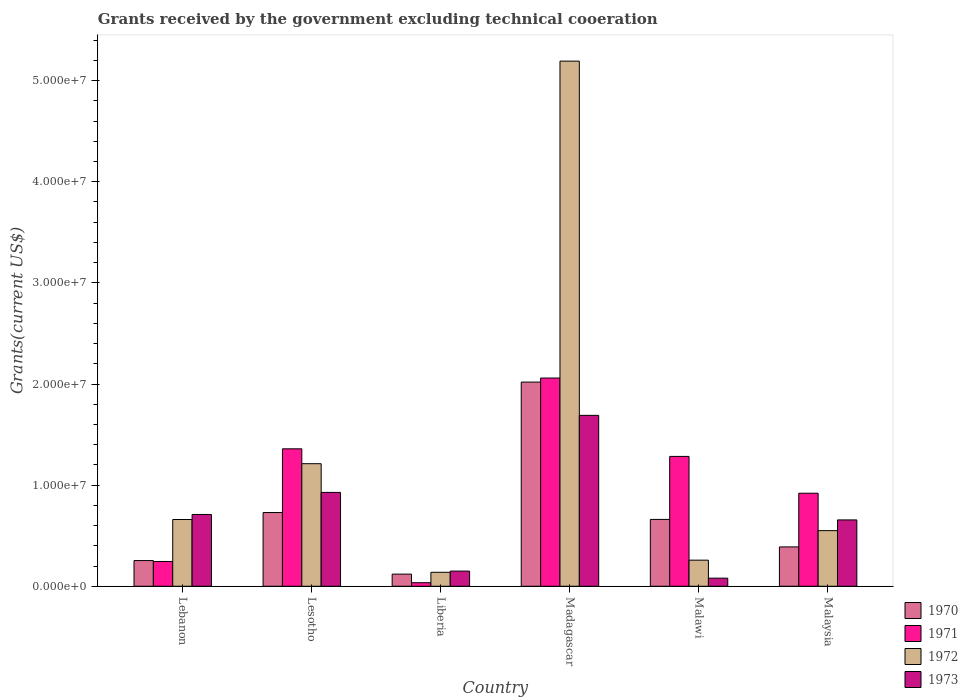How many groups of bars are there?
Give a very brief answer. 6. Are the number of bars on each tick of the X-axis equal?
Ensure brevity in your answer.  Yes. What is the label of the 6th group of bars from the left?
Offer a terse response. Malaysia. What is the total grants received by the government in 1972 in Lesotho?
Give a very brief answer. 1.21e+07. Across all countries, what is the maximum total grants received by the government in 1973?
Ensure brevity in your answer.  1.69e+07. Across all countries, what is the minimum total grants received by the government in 1970?
Provide a short and direct response. 1.20e+06. In which country was the total grants received by the government in 1973 maximum?
Provide a succinct answer. Madagascar. In which country was the total grants received by the government in 1970 minimum?
Offer a terse response. Liberia. What is the total total grants received by the government in 1970 in the graph?
Provide a succinct answer. 4.17e+07. What is the difference between the total grants received by the government in 1973 in Lesotho and that in Malaysia?
Provide a succinct answer. 2.72e+06. What is the difference between the total grants received by the government in 1972 in Malaysia and the total grants received by the government in 1973 in Madagascar?
Ensure brevity in your answer.  -1.14e+07. What is the average total grants received by the government in 1970 per country?
Provide a short and direct response. 6.95e+06. What is the difference between the total grants received by the government of/in 1970 and total grants received by the government of/in 1971 in Madagascar?
Provide a succinct answer. -4.00e+05. What is the ratio of the total grants received by the government in 1970 in Lebanon to that in Madagascar?
Offer a terse response. 0.13. Is the difference between the total grants received by the government in 1970 in Lebanon and Liberia greater than the difference between the total grants received by the government in 1971 in Lebanon and Liberia?
Offer a very short reply. No. What is the difference between the highest and the second highest total grants received by the government in 1972?
Provide a short and direct response. 4.53e+07. What is the difference between the highest and the lowest total grants received by the government in 1972?
Give a very brief answer. 5.06e+07. What does the 1st bar from the left in Madagascar represents?
Offer a terse response. 1970. Is it the case that in every country, the sum of the total grants received by the government in 1970 and total grants received by the government in 1972 is greater than the total grants received by the government in 1973?
Keep it short and to the point. Yes. How many bars are there?
Ensure brevity in your answer.  24. Are all the bars in the graph horizontal?
Give a very brief answer. No. What is the difference between two consecutive major ticks on the Y-axis?
Give a very brief answer. 1.00e+07. Does the graph contain grids?
Your answer should be compact. No. How many legend labels are there?
Ensure brevity in your answer.  4. How are the legend labels stacked?
Your answer should be compact. Vertical. What is the title of the graph?
Your answer should be very brief. Grants received by the government excluding technical cooeration. Does "1989" appear as one of the legend labels in the graph?
Your response must be concise. No. What is the label or title of the Y-axis?
Offer a very short reply. Grants(current US$). What is the Grants(current US$) in 1970 in Lebanon?
Keep it short and to the point. 2.54e+06. What is the Grants(current US$) of 1971 in Lebanon?
Your response must be concise. 2.45e+06. What is the Grants(current US$) in 1972 in Lebanon?
Ensure brevity in your answer.  6.60e+06. What is the Grants(current US$) of 1973 in Lebanon?
Your response must be concise. 7.10e+06. What is the Grants(current US$) of 1970 in Lesotho?
Offer a terse response. 7.29e+06. What is the Grants(current US$) of 1971 in Lesotho?
Offer a very short reply. 1.36e+07. What is the Grants(current US$) of 1972 in Lesotho?
Ensure brevity in your answer.  1.21e+07. What is the Grants(current US$) of 1973 in Lesotho?
Provide a succinct answer. 9.28e+06. What is the Grants(current US$) of 1970 in Liberia?
Make the answer very short. 1.20e+06. What is the Grants(current US$) of 1971 in Liberia?
Your response must be concise. 3.50e+05. What is the Grants(current US$) in 1972 in Liberia?
Keep it short and to the point. 1.38e+06. What is the Grants(current US$) in 1973 in Liberia?
Your response must be concise. 1.50e+06. What is the Grants(current US$) of 1970 in Madagascar?
Your response must be concise. 2.02e+07. What is the Grants(current US$) in 1971 in Madagascar?
Provide a short and direct response. 2.06e+07. What is the Grants(current US$) in 1972 in Madagascar?
Ensure brevity in your answer.  5.19e+07. What is the Grants(current US$) in 1973 in Madagascar?
Your answer should be very brief. 1.69e+07. What is the Grants(current US$) of 1970 in Malawi?
Offer a terse response. 6.61e+06. What is the Grants(current US$) in 1971 in Malawi?
Your answer should be compact. 1.28e+07. What is the Grants(current US$) of 1972 in Malawi?
Your answer should be compact. 2.58e+06. What is the Grants(current US$) of 1973 in Malawi?
Offer a very short reply. 8.00e+05. What is the Grants(current US$) of 1970 in Malaysia?
Provide a short and direct response. 3.89e+06. What is the Grants(current US$) of 1971 in Malaysia?
Your answer should be compact. 9.20e+06. What is the Grants(current US$) of 1972 in Malaysia?
Offer a very short reply. 5.50e+06. What is the Grants(current US$) of 1973 in Malaysia?
Your answer should be very brief. 6.56e+06. Across all countries, what is the maximum Grants(current US$) in 1970?
Your response must be concise. 2.02e+07. Across all countries, what is the maximum Grants(current US$) in 1971?
Keep it short and to the point. 2.06e+07. Across all countries, what is the maximum Grants(current US$) in 1972?
Ensure brevity in your answer.  5.19e+07. Across all countries, what is the maximum Grants(current US$) of 1973?
Keep it short and to the point. 1.69e+07. Across all countries, what is the minimum Grants(current US$) of 1970?
Give a very brief answer. 1.20e+06. Across all countries, what is the minimum Grants(current US$) of 1971?
Give a very brief answer. 3.50e+05. Across all countries, what is the minimum Grants(current US$) in 1972?
Your response must be concise. 1.38e+06. Across all countries, what is the minimum Grants(current US$) in 1973?
Make the answer very short. 8.00e+05. What is the total Grants(current US$) of 1970 in the graph?
Ensure brevity in your answer.  4.17e+07. What is the total Grants(current US$) of 1971 in the graph?
Your answer should be very brief. 5.90e+07. What is the total Grants(current US$) of 1972 in the graph?
Offer a very short reply. 8.01e+07. What is the total Grants(current US$) of 1973 in the graph?
Your answer should be very brief. 4.21e+07. What is the difference between the Grants(current US$) of 1970 in Lebanon and that in Lesotho?
Keep it short and to the point. -4.75e+06. What is the difference between the Grants(current US$) in 1971 in Lebanon and that in Lesotho?
Offer a very short reply. -1.11e+07. What is the difference between the Grants(current US$) of 1972 in Lebanon and that in Lesotho?
Offer a very short reply. -5.52e+06. What is the difference between the Grants(current US$) of 1973 in Lebanon and that in Lesotho?
Your answer should be very brief. -2.18e+06. What is the difference between the Grants(current US$) in 1970 in Lebanon and that in Liberia?
Provide a succinct answer. 1.34e+06. What is the difference between the Grants(current US$) in 1971 in Lebanon and that in Liberia?
Offer a very short reply. 2.10e+06. What is the difference between the Grants(current US$) of 1972 in Lebanon and that in Liberia?
Give a very brief answer. 5.22e+06. What is the difference between the Grants(current US$) of 1973 in Lebanon and that in Liberia?
Your response must be concise. 5.60e+06. What is the difference between the Grants(current US$) in 1970 in Lebanon and that in Madagascar?
Offer a very short reply. -1.76e+07. What is the difference between the Grants(current US$) in 1971 in Lebanon and that in Madagascar?
Ensure brevity in your answer.  -1.81e+07. What is the difference between the Grants(current US$) of 1972 in Lebanon and that in Madagascar?
Provide a succinct answer. -4.53e+07. What is the difference between the Grants(current US$) in 1973 in Lebanon and that in Madagascar?
Offer a very short reply. -9.80e+06. What is the difference between the Grants(current US$) of 1970 in Lebanon and that in Malawi?
Give a very brief answer. -4.07e+06. What is the difference between the Grants(current US$) in 1971 in Lebanon and that in Malawi?
Your response must be concise. -1.04e+07. What is the difference between the Grants(current US$) of 1972 in Lebanon and that in Malawi?
Your answer should be very brief. 4.02e+06. What is the difference between the Grants(current US$) in 1973 in Lebanon and that in Malawi?
Your response must be concise. 6.30e+06. What is the difference between the Grants(current US$) in 1970 in Lebanon and that in Malaysia?
Keep it short and to the point. -1.35e+06. What is the difference between the Grants(current US$) of 1971 in Lebanon and that in Malaysia?
Your response must be concise. -6.75e+06. What is the difference between the Grants(current US$) of 1972 in Lebanon and that in Malaysia?
Provide a short and direct response. 1.10e+06. What is the difference between the Grants(current US$) in 1973 in Lebanon and that in Malaysia?
Offer a terse response. 5.40e+05. What is the difference between the Grants(current US$) of 1970 in Lesotho and that in Liberia?
Make the answer very short. 6.09e+06. What is the difference between the Grants(current US$) in 1971 in Lesotho and that in Liberia?
Keep it short and to the point. 1.32e+07. What is the difference between the Grants(current US$) in 1972 in Lesotho and that in Liberia?
Offer a very short reply. 1.07e+07. What is the difference between the Grants(current US$) of 1973 in Lesotho and that in Liberia?
Provide a succinct answer. 7.78e+06. What is the difference between the Grants(current US$) in 1970 in Lesotho and that in Madagascar?
Your answer should be compact. -1.29e+07. What is the difference between the Grants(current US$) of 1971 in Lesotho and that in Madagascar?
Your answer should be very brief. -7.00e+06. What is the difference between the Grants(current US$) of 1972 in Lesotho and that in Madagascar?
Your response must be concise. -3.98e+07. What is the difference between the Grants(current US$) in 1973 in Lesotho and that in Madagascar?
Your response must be concise. -7.62e+06. What is the difference between the Grants(current US$) of 1970 in Lesotho and that in Malawi?
Your answer should be very brief. 6.80e+05. What is the difference between the Grants(current US$) of 1971 in Lesotho and that in Malawi?
Make the answer very short. 7.50e+05. What is the difference between the Grants(current US$) of 1972 in Lesotho and that in Malawi?
Keep it short and to the point. 9.54e+06. What is the difference between the Grants(current US$) of 1973 in Lesotho and that in Malawi?
Provide a succinct answer. 8.48e+06. What is the difference between the Grants(current US$) of 1970 in Lesotho and that in Malaysia?
Offer a very short reply. 3.40e+06. What is the difference between the Grants(current US$) in 1971 in Lesotho and that in Malaysia?
Your response must be concise. 4.39e+06. What is the difference between the Grants(current US$) in 1972 in Lesotho and that in Malaysia?
Your response must be concise. 6.62e+06. What is the difference between the Grants(current US$) in 1973 in Lesotho and that in Malaysia?
Ensure brevity in your answer.  2.72e+06. What is the difference between the Grants(current US$) in 1970 in Liberia and that in Madagascar?
Ensure brevity in your answer.  -1.90e+07. What is the difference between the Grants(current US$) of 1971 in Liberia and that in Madagascar?
Make the answer very short. -2.02e+07. What is the difference between the Grants(current US$) in 1972 in Liberia and that in Madagascar?
Give a very brief answer. -5.06e+07. What is the difference between the Grants(current US$) of 1973 in Liberia and that in Madagascar?
Your answer should be compact. -1.54e+07. What is the difference between the Grants(current US$) of 1970 in Liberia and that in Malawi?
Offer a very short reply. -5.41e+06. What is the difference between the Grants(current US$) of 1971 in Liberia and that in Malawi?
Offer a terse response. -1.25e+07. What is the difference between the Grants(current US$) in 1972 in Liberia and that in Malawi?
Your answer should be compact. -1.20e+06. What is the difference between the Grants(current US$) in 1973 in Liberia and that in Malawi?
Your answer should be compact. 7.00e+05. What is the difference between the Grants(current US$) in 1970 in Liberia and that in Malaysia?
Keep it short and to the point. -2.69e+06. What is the difference between the Grants(current US$) in 1971 in Liberia and that in Malaysia?
Offer a terse response. -8.85e+06. What is the difference between the Grants(current US$) of 1972 in Liberia and that in Malaysia?
Your response must be concise. -4.12e+06. What is the difference between the Grants(current US$) in 1973 in Liberia and that in Malaysia?
Give a very brief answer. -5.06e+06. What is the difference between the Grants(current US$) of 1970 in Madagascar and that in Malawi?
Provide a short and direct response. 1.36e+07. What is the difference between the Grants(current US$) of 1971 in Madagascar and that in Malawi?
Give a very brief answer. 7.75e+06. What is the difference between the Grants(current US$) in 1972 in Madagascar and that in Malawi?
Provide a short and direct response. 4.94e+07. What is the difference between the Grants(current US$) in 1973 in Madagascar and that in Malawi?
Offer a very short reply. 1.61e+07. What is the difference between the Grants(current US$) in 1970 in Madagascar and that in Malaysia?
Give a very brief answer. 1.63e+07. What is the difference between the Grants(current US$) of 1971 in Madagascar and that in Malaysia?
Your response must be concise. 1.14e+07. What is the difference between the Grants(current US$) in 1972 in Madagascar and that in Malaysia?
Offer a terse response. 4.64e+07. What is the difference between the Grants(current US$) of 1973 in Madagascar and that in Malaysia?
Provide a succinct answer. 1.03e+07. What is the difference between the Grants(current US$) of 1970 in Malawi and that in Malaysia?
Provide a succinct answer. 2.72e+06. What is the difference between the Grants(current US$) in 1971 in Malawi and that in Malaysia?
Make the answer very short. 3.64e+06. What is the difference between the Grants(current US$) of 1972 in Malawi and that in Malaysia?
Your answer should be very brief. -2.92e+06. What is the difference between the Grants(current US$) of 1973 in Malawi and that in Malaysia?
Offer a very short reply. -5.76e+06. What is the difference between the Grants(current US$) of 1970 in Lebanon and the Grants(current US$) of 1971 in Lesotho?
Provide a short and direct response. -1.10e+07. What is the difference between the Grants(current US$) of 1970 in Lebanon and the Grants(current US$) of 1972 in Lesotho?
Ensure brevity in your answer.  -9.58e+06. What is the difference between the Grants(current US$) of 1970 in Lebanon and the Grants(current US$) of 1973 in Lesotho?
Your answer should be very brief. -6.74e+06. What is the difference between the Grants(current US$) in 1971 in Lebanon and the Grants(current US$) in 1972 in Lesotho?
Make the answer very short. -9.67e+06. What is the difference between the Grants(current US$) in 1971 in Lebanon and the Grants(current US$) in 1973 in Lesotho?
Keep it short and to the point. -6.83e+06. What is the difference between the Grants(current US$) in 1972 in Lebanon and the Grants(current US$) in 1973 in Lesotho?
Your answer should be compact. -2.68e+06. What is the difference between the Grants(current US$) of 1970 in Lebanon and the Grants(current US$) of 1971 in Liberia?
Keep it short and to the point. 2.19e+06. What is the difference between the Grants(current US$) in 1970 in Lebanon and the Grants(current US$) in 1972 in Liberia?
Give a very brief answer. 1.16e+06. What is the difference between the Grants(current US$) in 1970 in Lebanon and the Grants(current US$) in 1973 in Liberia?
Your answer should be very brief. 1.04e+06. What is the difference between the Grants(current US$) in 1971 in Lebanon and the Grants(current US$) in 1972 in Liberia?
Provide a short and direct response. 1.07e+06. What is the difference between the Grants(current US$) of 1971 in Lebanon and the Grants(current US$) of 1973 in Liberia?
Make the answer very short. 9.50e+05. What is the difference between the Grants(current US$) in 1972 in Lebanon and the Grants(current US$) in 1973 in Liberia?
Give a very brief answer. 5.10e+06. What is the difference between the Grants(current US$) in 1970 in Lebanon and the Grants(current US$) in 1971 in Madagascar?
Make the answer very short. -1.80e+07. What is the difference between the Grants(current US$) in 1970 in Lebanon and the Grants(current US$) in 1972 in Madagascar?
Your answer should be very brief. -4.94e+07. What is the difference between the Grants(current US$) in 1970 in Lebanon and the Grants(current US$) in 1973 in Madagascar?
Your response must be concise. -1.44e+07. What is the difference between the Grants(current US$) in 1971 in Lebanon and the Grants(current US$) in 1972 in Madagascar?
Provide a succinct answer. -4.95e+07. What is the difference between the Grants(current US$) of 1971 in Lebanon and the Grants(current US$) of 1973 in Madagascar?
Offer a terse response. -1.44e+07. What is the difference between the Grants(current US$) in 1972 in Lebanon and the Grants(current US$) in 1973 in Madagascar?
Make the answer very short. -1.03e+07. What is the difference between the Grants(current US$) of 1970 in Lebanon and the Grants(current US$) of 1971 in Malawi?
Ensure brevity in your answer.  -1.03e+07. What is the difference between the Grants(current US$) in 1970 in Lebanon and the Grants(current US$) in 1972 in Malawi?
Provide a succinct answer. -4.00e+04. What is the difference between the Grants(current US$) in 1970 in Lebanon and the Grants(current US$) in 1973 in Malawi?
Your answer should be very brief. 1.74e+06. What is the difference between the Grants(current US$) in 1971 in Lebanon and the Grants(current US$) in 1972 in Malawi?
Offer a terse response. -1.30e+05. What is the difference between the Grants(current US$) in 1971 in Lebanon and the Grants(current US$) in 1973 in Malawi?
Make the answer very short. 1.65e+06. What is the difference between the Grants(current US$) in 1972 in Lebanon and the Grants(current US$) in 1973 in Malawi?
Your response must be concise. 5.80e+06. What is the difference between the Grants(current US$) of 1970 in Lebanon and the Grants(current US$) of 1971 in Malaysia?
Offer a very short reply. -6.66e+06. What is the difference between the Grants(current US$) of 1970 in Lebanon and the Grants(current US$) of 1972 in Malaysia?
Your response must be concise. -2.96e+06. What is the difference between the Grants(current US$) in 1970 in Lebanon and the Grants(current US$) in 1973 in Malaysia?
Offer a terse response. -4.02e+06. What is the difference between the Grants(current US$) in 1971 in Lebanon and the Grants(current US$) in 1972 in Malaysia?
Offer a very short reply. -3.05e+06. What is the difference between the Grants(current US$) in 1971 in Lebanon and the Grants(current US$) in 1973 in Malaysia?
Keep it short and to the point. -4.11e+06. What is the difference between the Grants(current US$) of 1972 in Lebanon and the Grants(current US$) of 1973 in Malaysia?
Offer a terse response. 4.00e+04. What is the difference between the Grants(current US$) in 1970 in Lesotho and the Grants(current US$) in 1971 in Liberia?
Give a very brief answer. 6.94e+06. What is the difference between the Grants(current US$) of 1970 in Lesotho and the Grants(current US$) of 1972 in Liberia?
Make the answer very short. 5.91e+06. What is the difference between the Grants(current US$) in 1970 in Lesotho and the Grants(current US$) in 1973 in Liberia?
Your answer should be compact. 5.79e+06. What is the difference between the Grants(current US$) in 1971 in Lesotho and the Grants(current US$) in 1972 in Liberia?
Keep it short and to the point. 1.22e+07. What is the difference between the Grants(current US$) in 1971 in Lesotho and the Grants(current US$) in 1973 in Liberia?
Your response must be concise. 1.21e+07. What is the difference between the Grants(current US$) of 1972 in Lesotho and the Grants(current US$) of 1973 in Liberia?
Offer a terse response. 1.06e+07. What is the difference between the Grants(current US$) in 1970 in Lesotho and the Grants(current US$) in 1971 in Madagascar?
Give a very brief answer. -1.33e+07. What is the difference between the Grants(current US$) of 1970 in Lesotho and the Grants(current US$) of 1972 in Madagascar?
Your response must be concise. -4.46e+07. What is the difference between the Grants(current US$) of 1970 in Lesotho and the Grants(current US$) of 1973 in Madagascar?
Your answer should be compact. -9.61e+06. What is the difference between the Grants(current US$) of 1971 in Lesotho and the Grants(current US$) of 1972 in Madagascar?
Offer a very short reply. -3.83e+07. What is the difference between the Grants(current US$) of 1971 in Lesotho and the Grants(current US$) of 1973 in Madagascar?
Give a very brief answer. -3.31e+06. What is the difference between the Grants(current US$) of 1972 in Lesotho and the Grants(current US$) of 1973 in Madagascar?
Your answer should be very brief. -4.78e+06. What is the difference between the Grants(current US$) in 1970 in Lesotho and the Grants(current US$) in 1971 in Malawi?
Provide a succinct answer. -5.55e+06. What is the difference between the Grants(current US$) of 1970 in Lesotho and the Grants(current US$) of 1972 in Malawi?
Give a very brief answer. 4.71e+06. What is the difference between the Grants(current US$) of 1970 in Lesotho and the Grants(current US$) of 1973 in Malawi?
Your answer should be very brief. 6.49e+06. What is the difference between the Grants(current US$) in 1971 in Lesotho and the Grants(current US$) in 1972 in Malawi?
Offer a terse response. 1.10e+07. What is the difference between the Grants(current US$) of 1971 in Lesotho and the Grants(current US$) of 1973 in Malawi?
Offer a terse response. 1.28e+07. What is the difference between the Grants(current US$) in 1972 in Lesotho and the Grants(current US$) in 1973 in Malawi?
Provide a succinct answer. 1.13e+07. What is the difference between the Grants(current US$) in 1970 in Lesotho and the Grants(current US$) in 1971 in Malaysia?
Your answer should be compact. -1.91e+06. What is the difference between the Grants(current US$) of 1970 in Lesotho and the Grants(current US$) of 1972 in Malaysia?
Give a very brief answer. 1.79e+06. What is the difference between the Grants(current US$) in 1970 in Lesotho and the Grants(current US$) in 1973 in Malaysia?
Provide a succinct answer. 7.30e+05. What is the difference between the Grants(current US$) of 1971 in Lesotho and the Grants(current US$) of 1972 in Malaysia?
Offer a very short reply. 8.09e+06. What is the difference between the Grants(current US$) in 1971 in Lesotho and the Grants(current US$) in 1973 in Malaysia?
Offer a very short reply. 7.03e+06. What is the difference between the Grants(current US$) of 1972 in Lesotho and the Grants(current US$) of 1973 in Malaysia?
Keep it short and to the point. 5.56e+06. What is the difference between the Grants(current US$) in 1970 in Liberia and the Grants(current US$) in 1971 in Madagascar?
Provide a short and direct response. -1.94e+07. What is the difference between the Grants(current US$) in 1970 in Liberia and the Grants(current US$) in 1972 in Madagascar?
Your answer should be very brief. -5.07e+07. What is the difference between the Grants(current US$) of 1970 in Liberia and the Grants(current US$) of 1973 in Madagascar?
Ensure brevity in your answer.  -1.57e+07. What is the difference between the Grants(current US$) of 1971 in Liberia and the Grants(current US$) of 1972 in Madagascar?
Offer a very short reply. -5.16e+07. What is the difference between the Grants(current US$) in 1971 in Liberia and the Grants(current US$) in 1973 in Madagascar?
Your answer should be very brief. -1.66e+07. What is the difference between the Grants(current US$) in 1972 in Liberia and the Grants(current US$) in 1973 in Madagascar?
Make the answer very short. -1.55e+07. What is the difference between the Grants(current US$) of 1970 in Liberia and the Grants(current US$) of 1971 in Malawi?
Keep it short and to the point. -1.16e+07. What is the difference between the Grants(current US$) of 1970 in Liberia and the Grants(current US$) of 1972 in Malawi?
Give a very brief answer. -1.38e+06. What is the difference between the Grants(current US$) of 1970 in Liberia and the Grants(current US$) of 1973 in Malawi?
Give a very brief answer. 4.00e+05. What is the difference between the Grants(current US$) of 1971 in Liberia and the Grants(current US$) of 1972 in Malawi?
Ensure brevity in your answer.  -2.23e+06. What is the difference between the Grants(current US$) of 1971 in Liberia and the Grants(current US$) of 1973 in Malawi?
Provide a succinct answer. -4.50e+05. What is the difference between the Grants(current US$) in 1972 in Liberia and the Grants(current US$) in 1973 in Malawi?
Offer a terse response. 5.80e+05. What is the difference between the Grants(current US$) in 1970 in Liberia and the Grants(current US$) in 1971 in Malaysia?
Make the answer very short. -8.00e+06. What is the difference between the Grants(current US$) in 1970 in Liberia and the Grants(current US$) in 1972 in Malaysia?
Give a very brief answer. -4.30e+06. What is the difference between the Grants(current US$) of 1970 in Liberia and the Grants(current US$) of 1973 in Malaysia?
Your answer should be compact. -5.36e+06. What is the difference between the Grants(current US$) of 1971 in Liberia and the Grants(current US$) of 1972 in Malaysia?
Keep it short and to the point. -5.15e+06. What is the difference between the Grants(current US$) of 1971 in Liberia and the Grants(current US$) of 1973 in Malaysia?
Provide a succinct answer. -6.21e+06. What is the difference between the Grants(current US$) in 1972 in Liberia and the Grants(current US$) in 1973 in Malaysia?
Offer a terse response. -5.18e+06. What is the difference between the Grants(current US$) of 1970 in Madagascar and the Grants(current US$) of 1971 in Malawi?
Ensure brevity in your answer.  7.35e+06. What is the difference between the Grants(current US$) of 1970 in Madagascar and the Grants(current US$) of 1972 in Malawi?
Provide a succinct answer. 1.76e+07. What is the difference between the Grants(current US$) of 1970 in Madagascar and the Grants(current US$) of 1973 in Malawi?
Keep it short and to the point. 1.94e+07. What is the difference between the Grants(current US$) in 1971 in Madagascar and the Grants(current US$) in 1972 in Malawi?
Keep it short and to the point. 1.80e+07. What is the difference between the Grants(current US$) of 1971 in Madagascar and the Grants(current US$) of 1973 in Malawi?
Make the answer very short. 1.98e+07. What is the difference between the Grants(current US$) of 1972 in Madagascar and the Grants(current US$) of 1973 in Malawi?
Your response must be concise. 5.11e+07. What is the difference between the Grants(current US$) of 1970 in Madagascar and the Grants(current US$) of 1971 in Malaysia?
Give a very brief answer. 1.10e+07. What is the difference between the Grants(current US$) in 1970 in Madagascar and the Grants(current US$) in 1972 in Malaysia?
Keep it short and to the point. 1.47e+07. What is the difference between the Grants(current US$) in 1970 in Madagascar and the Grants(current US$) in 1973 in Malaysia?
Provide a short and direct response. 1.36e+07. What is the difference between the Grants(current US$) of 1971 in Madagascar and the Grants(current US$) of 1972 in Malaysia?
Offer a very short reply. 1.51e+07. What is the difference between the Grants(current US$) of 1971 in Madagascar and the Grants(current US$) of 1973 in Malaysia?
Make the answer very short. 1.40e+07. What is the difference between the Grants(current US$) of 1972 in Madagascar and the Grants(current US$) of 1973 in Malaysia?
Offer a terse response. 4.54e+07. What is the difference between the Grants(current US$) in 1970 in Malawi and the Grants(current US$) in 1971 in Malaysia?
Ensure brevity in your answer.  -2.59e+06. What is the difference between the Grants(current US$) of 1970 in Malawi and the Grants(current US$) of 1972 in Malaysia?
Offer a very short reply. 1.11e+06. What is the difference between the Grants(current US$) in 1971 in Malawi and the Grants(current US$) in 1972 in Malaysia?
Your answer should be compact. 7.34e+06. What is the difference between the Grants(current US$) of 1971 in Malawi and the Grants(current US$) of 1973 in Malaysia?
Offer a very short reply. 6.28e+06. What is the difference between the Grants(current US$) of 1972 in Malawi and the Grants(current US$) of 1973 in Malaysia?
Offer a terse response. -3.98e+06. What is the average Grants(current US$) of 1970 per country?
Your answer should be compact. 6.95e+06. What is the average Grants(current US$) in 1971 per country?
Give a very brief answer. 9.84e+06. What is the average Grants(current US$) of 1972 per country?
Give a very brief answer. 1.34e+07. What is the average Grants(current US$) of 1973 per country?
Provide a short and direct response. 7.02e+06. What is the difference between the Grants(current US$) of 1970 and Grants(current US$) of 1972 in Lebanon?
Provide a short and direct response. -4.06e+06. What is the difference between the Grants(current US$) in 1970 and Grants(current US$) in 1973 in Lebanon?
Provide a short and direct response. -4.56e+06. What is the difference between the Grants(current US$) in 1971 and Grants(current US$) in 1972 in Lebanon?
Your response must be concise. -4.15e+06. What is the difference between the Grants(current US$) in 1971 and Grants(current US$) in 1973 in Lebanon?
Provide a succinct answer. -4.65e+06. What is the difference between the Grants(current US$) in 1972 and Grants(current US$) in 1973 in Lebanon?
Offer a very short reply. -5.00e+05. What is the difference between the Grants(current US$) of 1970 and Grants(current US$) of 1971 in Lesotho?
Give a very brief answer. -6.30e+06. What is the difference between the Grants(current US$) in 1970 and Grants(current US$) in 1972 in Lesotho?
Make the answer very short. -4.83e+06. What is the difference between the Grants(current US$) in 1970 and Grants(current US$) in 1973 in Lesotho?
Keep it short and to the point. -1.99e+06. What is the difference between the Grants(current US$) in 1971 and Grants(current US$) in 1972 in Lesotho?
Keep it short and to the point. 1.47e+06. What is the difference between the Grants(current US$) of 1971 and Grants(current US$) of 1973 in Lesotho?
Provide a succinct answer. 4.31e+06. What is the difference between the Grants(current US$) in 1972 and Grants(current US$) in 1973 in Lesotho?
Give a very brief answer. 2.84e+06. What is the difference between the Grants(current US$) in 1970 and Grants(current US$) in 1971 in Liberia?
Give a very brief answer. 8.50e+05. What is the difference between the Grants(current US$) in 1970 and Grants(current US$) in 1973 in Liberia?
Your answer should be very brief. -3.00e+05. What is the difference between the Grants(current US$) of 1971 and Grants(current US$) of 1972 in Liberia?
Your response must be concise. -1.03e+06. What is the difference between the Grants(current US$) in 1971 and Grants(current US$) in 1973 in Liberia?
Ensure brevity in your answer.  -1.15e+06. What is the difference between the Grants(current US$) of 1970 and Grants(current US$) of 1971 in Madagascar?
Make the answer very short. -4.00e+05. What is the difference between the Grants(current US$) of 1970 and Grants(current US$) of 1972 in Madagascar?
Give a very brief answer. -3.17e+07. What is the difference between the Grants(current US$) in 1970 and Grants(current US$) in 1973 in Madagascar?
Provide a succinct answer. 3.29e+06. What is the difference between the Grants(current US$) in 1971 and Grants(current US$) in 1972 in Madagascar?
Offer a very short reply. -3.13e+07. What is the difference between the Grants(current US$) of 1971 and Grants(current US$) of 1973 in Madagascar?
Your response must be concise. 3.69e+06. What is the difference between the Grants(current US$) in 1972 and Grants(current US$) in 1973 in Madagascar?
Provide a short and direct response. 3.50e+07. What is the difference between the Grants(current US$) of 1970 and Grants(current US$) of 1971 in Malawi?
Give a very brief answer. -6.23e+06. What is the difference between the Grants(current US$) of 1970 and Grants(current US$) of 1972 in Malawi?
Make the answer very short. 4.03e+06. What is the difference between the Grants(current US$) of 1970 and Grants(current US$) of 1973 in Malawi?
Offer a terse response. 5.81e+06. What is the difference between the Grants(current US$) in 1971 and Grants(current US$) in 1972 in Malawi?
Offer a terse response. 1.03e+07. What is the difference between the Grants(current US$) of 1971 and Grants(current US$) of 1973 in Malawi?
Your answer should be very brief. 1.20e+07. What is the difference between the Grants(current US$) of 1972 and Grants(current US$) of 1973 in Malawi?
Provide a short and direct response. 1.78e+06. What is the difference between the Grants(current US$) of 1970 and Grants(current US$) of 1971 in Malaysia?
Offer a very short reply. -5.31e+06. What is the difference between the Grants(current US$) in 1970 and Grants(current US$) in 1972 in Malaysia?
Provide a short and direct response. -1.61e+06. What is the difference between the Grants(current US$) of 1970 and Grants(current US$) of 1973 in Malaysia?
Provide a short and direct response. -2.67e+06. What is the difference between the Grants(current US$) in 1971 and Grants(current US$) in 1972 in Malaysia?
Offer a very short reply. 3.70e+06. What is the difference between the Grants(current US$) of 1971 and Grants(current US$) of 1973 in Malaysia?
Your answer should be compact. 2.64e+06. What is the difference between the Grants(current US$) of 1972 and Grants(current US$) of 1973 in Malaysia?
Give a very brief answer. -1.06e+06. What is the ratio of the Grants(current US$) of 1970 in Lebanon to that in Lesotho?
Your answer should be very brief. 0.35. What is the ratio of the Grants(current US$) in 1971 in Lebanon to that in Lesotho?
Provide a short and direct response. 0.18. What is the ratio of the Grants(current US$) of 1972 in Lebanon to that in Lesotho?
Offer a very short reply. 0.54. What is the ratio of the Grants(current US$) of 1973 in Lebanon to that in Lesotho?
Your response must be concise. 0.77. What is the ratio of the Grants(current US$) of 1970 in Lebanon to that in Liberia?
Offer a very short reply. 2.12. What is the ratio of the Grants(current US$) in 1971 in Lebanon to that in Liberia?
Offer a very short reply. 7. What is the ratio of the Grants(current US$) in 1972 in Lebanon to that in Liberia?
Give a very brief answer. 4.78. What is the ratio of the Grants(current US$) of 1973 in Lebanon to that in Liberia?
Ensure brevity in your answer.  4.73. What is the ratio of the Grants(current US$) in 1970 in Lebanon to that in Madagascar?
Ensure brevity in your answer.  0.13. What is the ratio of the Grants(current US$) in 1971 in Lebanon to that in Madagascar?
Make the answer very short. 0.12. What is the ratio of the Grants(current US$) of 1972 in Lebanon to that in Madagascar?
Keep it short and to the point. 0.13. What is the ratio of the Grants(current US$) of 1973 in Lebanon to that in Madagascar?
Give a very brief answer. 0.42. What is the ratio of the Grants(current US$) of 1970 in Lebanon to that in Malawi?
Give a very brief answer. 0.38. What is the ratio of the Grants(current US$) of 1971 in Lebanon to that in Malawi?
Keep it short and to the point. 0.19. What is the ratio of the Grants(current US$) of 1972 in Lebanon to that in Malawi?
Provide a succinct answer. 2.56. What is the ratio of the Grants(current US$) in 1973 in Lebanon to that in Malawi?
Give a very brief answer. 8.88. What is the ratio of the Grants(current US$) of 1970 in Lebanon to that in Malaysia?
Offer a terse response. 0.65. What is the ratio of the Grants(current US$) of 1971 in Lebanon to that in Malaysia?
Your response must be concise. 0.27. What is the ratio of the Grants(current US$) in 1973 in Lebanon to that in Malaysia?
Give a very brief answer. 1.08. What is the ratio of the Grants(current US$) of 1970 in Lesotho to that in Liberia?
Make the answer very short. 6.08. What is the ratio of the Grants(current US$) in 1971 in Lesotho to that in Liberia?
Provide a succinct answer. 38.83. What is the ratio of the Grants(current US$) in 1972 in Lesotho to that in Liberia?
Ensure brevity in your answer.  8.78. What is the ratio of the Grants(current US$) in 1973 in Lesotho to that in Liberia?
Provide a succinct answer. 6.19. What is the ratio of the Grants(current US$) of 1970 in Lesotho to that in Madagascar?
Your answer should be compact. 0.36. What is the ratio of the Grants(current US$) in 1971 in Lesotho to that in Madagascar?
Your response must be concise. 0.66. What is the ratio of the Grants(current US$) of 1972 in Lesotho to that in Madagascar?
Provide a succinct answer. 0.23. What is the ratio of the Grants(current US$) in 1973 in Lesotho to that in Madagascar?
Your answer should be compact. 0.55. What is the ratio of the Grants(current US$) in 1970 in Lesotho to that in Malawi?
Ensure brevity in your answer.  1.1. What is the ratio of the Grants(current US$) in 1971 in Lesotho to that in Malawi?
Your answer should be compact. 1.06. What is the ratio of the Grants(current US$) of 1972 in Lesotho to that in Malawi?
Your answer should be compact. 4.7. What is the ratio of the Grants(current US$) of 1970 in Lesotho to that in Malaysia?
Keep it short and to the point. 1.87. What is the ratio of the Grants(current US$) in 1971 in Lesotho to that in Malaysia?
Your answer should be compact. 1.48. What is the ratio of the Grants(current US$) in 1972 in Lesotho to that in Malaysia?
Offer a very short reply. 2.2. What is the ratio of the Grants(current US$) of 1973 in Lesotho to that in Malaysia?
Keep it short and to the point. 1.41. What is the ratio of the Grants(current US$) of 1970 in Liberia to that in Madagascar?
Your answer should be compact. 0.06. What is the ratio of the Grants(current US$) in 1971 in Liberia to that in Madagascar?
Give a very brief answer. 0.02. What is the ratio of the Grants(current US$) in 1972 in Liberia to that in Madagascar?
Ensure brevity in your answer.  0.03. What is the ratio of the Grants(current US$) of 1973 in Liberia to that in Madagascar?
Offer a terse response. 0.09. What is the ratio of the Grants(current US$) of 1970 in Liberia to that in Malawi?
Ensure brevity in your answer.  0.18. What is the ratio of the Grants(current US$) in 1971 in Liberia to that in Malawi?
Provide a succinct answer. 0.03. What is the ratio of the Grants(current US$) in 1972 in Liberia to that in Malawi?
Your answer should be very brief. 0.53. What is the ratio of the Grants(current US$) in 1973 in Liberia to that in Malawi?
Your answer should be compact. 1.88. What is the ratio of the Grants(current US$) in 1970 in Liberia to that in Malaysia?
Provide a succinct answer. 0.31. What is the ratio of the Grants(current US$) in 1971 in Liberia to that in Malaysia?
Your answer should be compact. 0.04. What is the ratio of the Grants(current US$) in 1972 in Liberia to that in Malaysia?
Your answer should be compact. 0.25. What is the ratio of the Grants(current US$) of 1973 in Liberia to that in Malaysia?
Offer a very short reply. 0.23. What is the ratio of the Grants(current US$) of 1970 in Madagascar to that in Malawi?
Your response must be concise. 3.05. What is the ratio of the Grants(current US$) of 1971 in Madagascar to that in Malawi?
Give a very brief answer. 1.6. What is the ratio of the Grants(current US$) of 1972 in Madagascar to that in Malawi?
Give a very brief answer. 20.13. What is the ratio of the Grants(current US$) in 1973 in Madagascar to that in Malawi?
Provide a succinct answer. 21.12. What is the ratio of the Grants(current US$) in 1970 in Madagascar to that in Malaysia?
Make the answer very short. 5.19. What is the ratio of the Grants(current US$) in 1971 in Madagascar to that in Malaysia?
Provide a short and direct response. 2.24. What is the ratio of the Grants(current US$) in 1972 in Madagascar to that in Malaysia?
Give a very brief answer. 9.44. What is the ratio of the Grants(current US$) in 1973 in Madagascar to that in Malaysia?
Your answer should be very brief. 2.58. What is the ratio of the Grants(current US$) of 1970 in Malawi to that in Malaysia?
Your answer should be compact. 1.7. What is the ratio of the Grants(current US$) in 1971 in Malawi to that in Malaysia?
Your response must be concise. 1.4. What is the ratio of the Grants(current US$) of 1972 in Malawi to that in Malaysia?
Offer a very short reply. 0.47. What is the ratio of the Grants(current US$) of 1973 in Malawi to that in Malaysia?
Offer a terse response. 0.12. What is the difference between the highest and the second highest Grants(current US$) of 1970?
Provide a short and direct response. 1.29e+07. What is the difference between the highest and the second highest Grants(current US$) in 1972?
Your response must be concise. 3.98e+07. What is the difference between the highest and the second highest Grants(current US$) of 1973?
Offer a very short reply. 7.62e+06. What is the difference between the highest and the lowest Grants(current US$) in 1970?
Your answer should be very brief. 1.90e+07. What is the difference between the highest and the lowest Grants(current US$) of 1971?
Keep it short and to the point. 2.02e+07. What is the difference between the highest and the lowest Grants(current US$) in 1972?
Ensure brevity in your answer.  5.06e+07. What is the difference between the highest and the lowest Grants(current US$) of 1973?
Ensure brevity in your answer.  1.61e+07. 